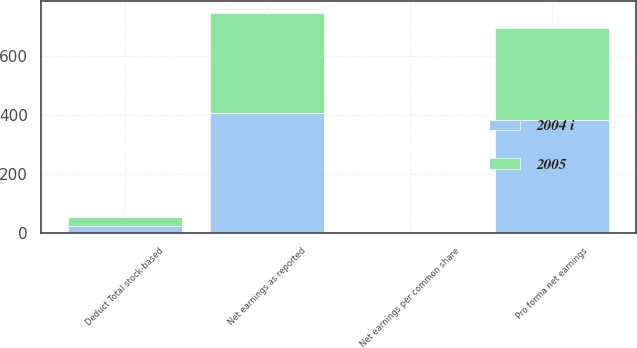Convert chart. <chart><loc_0><loc_0><loc_500><loc_500><stacked_bar_chart><ecel><fcel>Net earnings as reported<fcel>Deduct Total stock-based<fcel>Pro forma net earnings<fcel>Net earnings per common share<nl><fcel>2004 i<fcel>406.1<fcel>21.8<fcel>384.3<fcel>1.67<nl><fcel>2005<fcel>342.1<fcel>31.4<fcel>310.7<fcel>1.34<nl></chart> 